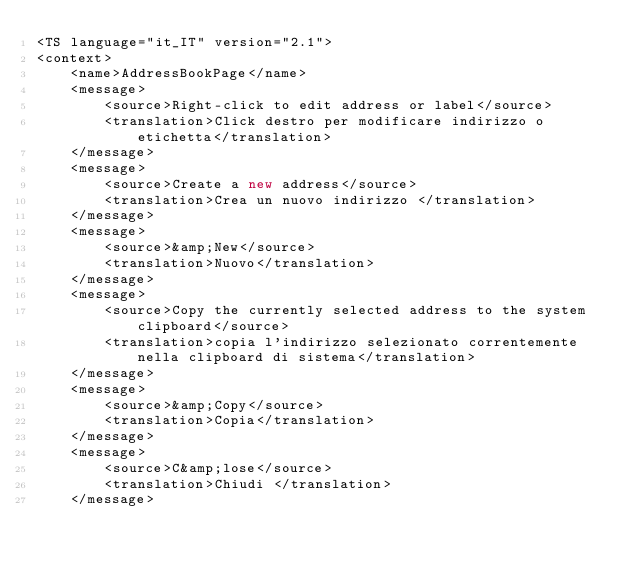<code> <loc_0><loc_0><loc_500><loc_500><_TypeScript_><TS language="it_IT" version="2.1">
<context>
    <name>AddressBookPage</name>
    <message>
        <source>Right-click to edit address or label</source>
        <translation>Click destro per modificare indirizzo o etichetta</translation>
    </message>
    <message>
        <source>Create a new address</source>
        <translation>Crea un nuovo indirizzo </translation>
    </message>
    <message>
        <source>&amp;New</source>
        <translation>Nuovo</translation>
    </message>
    <message>
        <source>Copy the currently selected address to the system clipboard</source>
        <translation>copia l'indirizzo selezionato correntemente nella clipboard di sistema</translation>
    </message>
    <message>
        <source>&amp;Copy</source>
        <translation>Copia</translation>
    </message>
    <message>
        <source>C&amp;lose</source>
        <translation>Chiudi </translation>
    </message></code> 